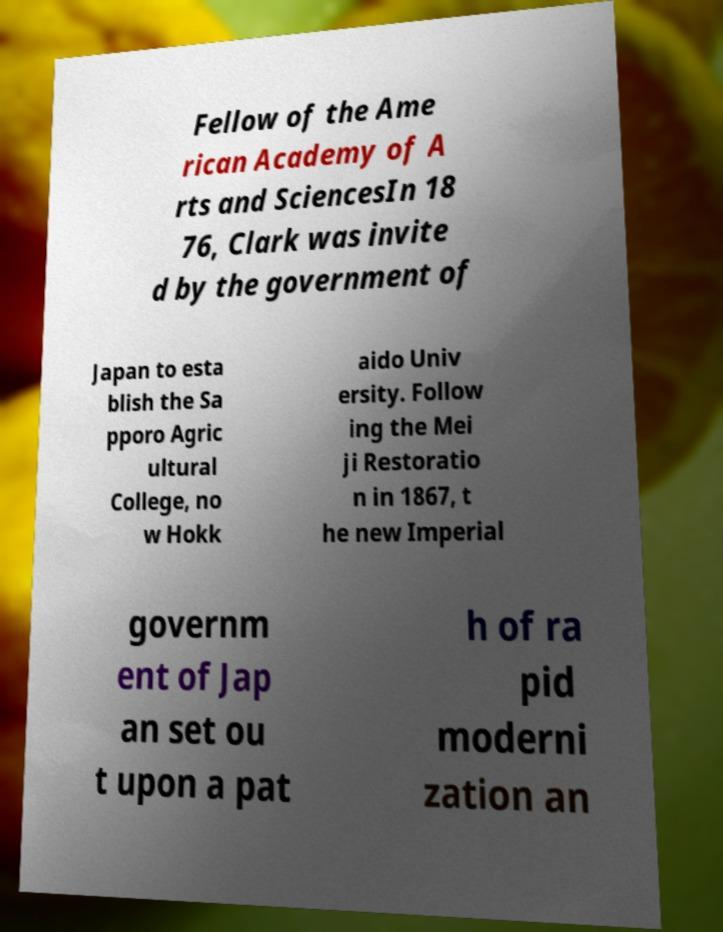For documentation purposes, I need the text within this image transcribed. Could you provide that? Fellow of the Ame rican Academy of A rts and SciencesIn 18 76, Clark was invite d by the government of Japan to esta blish the Sa pporo Agric ultural College, no w Hokk aido Univ ersity. Follow ing the Mei ji Restoratio n in 1867, t he new Imperial governm ent of Jap an set ou t upon a pat h of ra pid moderni zation an 